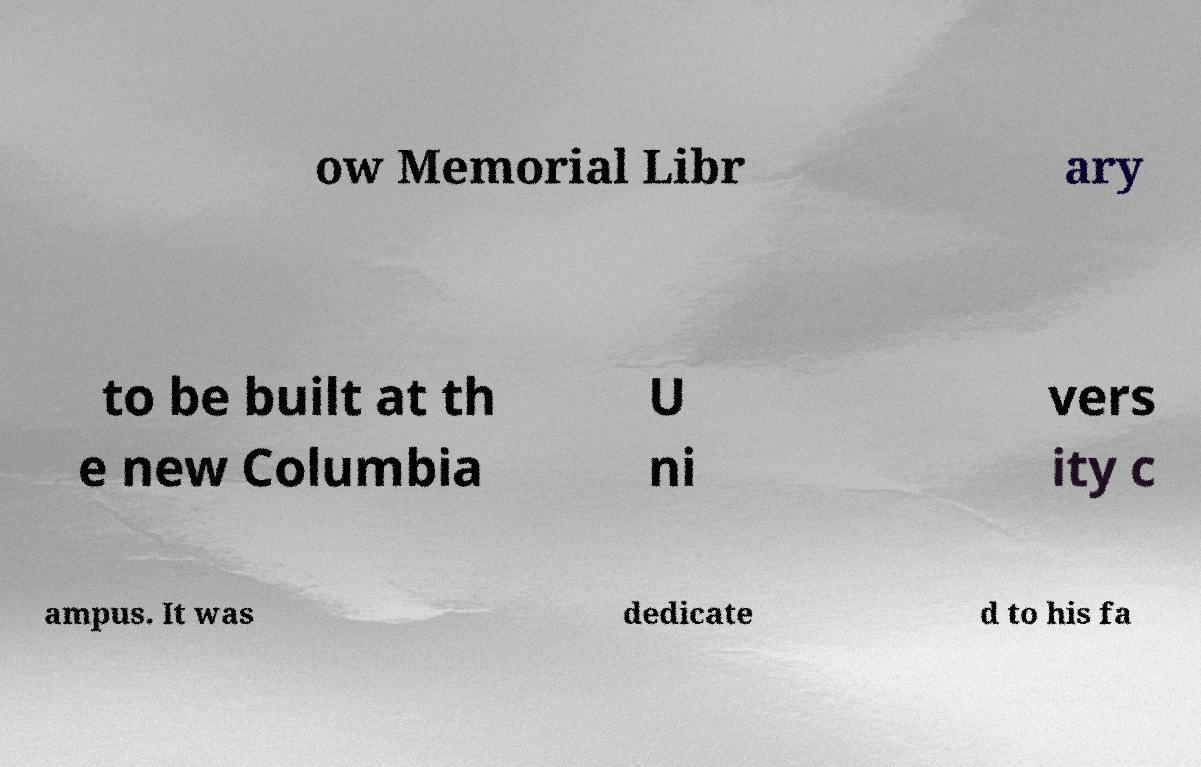Could you extract and type out the text from this image? ow Memorial Libr ary to be built at th e new Columbia U ni vers ity c ampus. It was dedicate d to his fa 